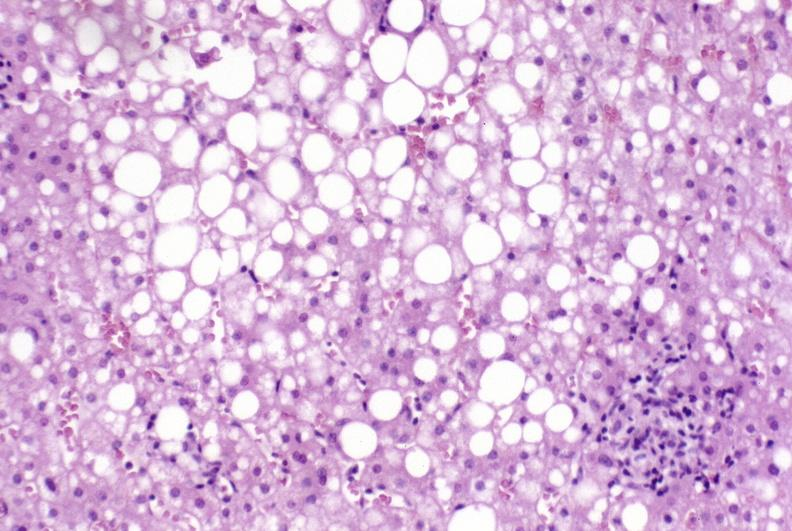does hypersegmented neutrophil show primary biliary cirrhosis?
Answer the question using a single word or phrase. No 